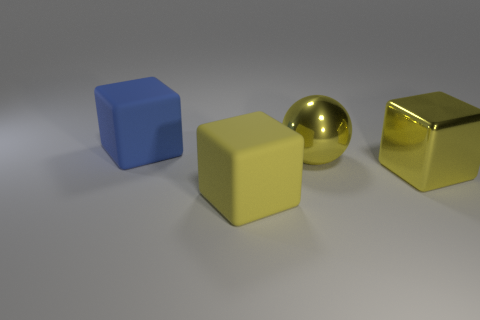Subtract all big yellow cubes. How many cubes are left? 1 Add 4 big yellow cubes. How many objects exist? 8 Subtract 2 cubes. How many cubes are left? 1 Subtract all blue blocks. How many blocks are left? 2 Subtract all green spheres. How many purple cubes are left? 0 Subtract all blue spheres. Subtract all cyan cubes. How many spheres are left? 1 Subtract all yellow matte objects. Subtract all big gray shiny cubes. How many objects are left? 3 Add 3 big matte blocks. How many big matte blocks are left? 5 Add 2 large yellow matte cubes. How many large yellow matte cubes exist? 3 Subtract 0 red cylinders. How many objects are left? 4 